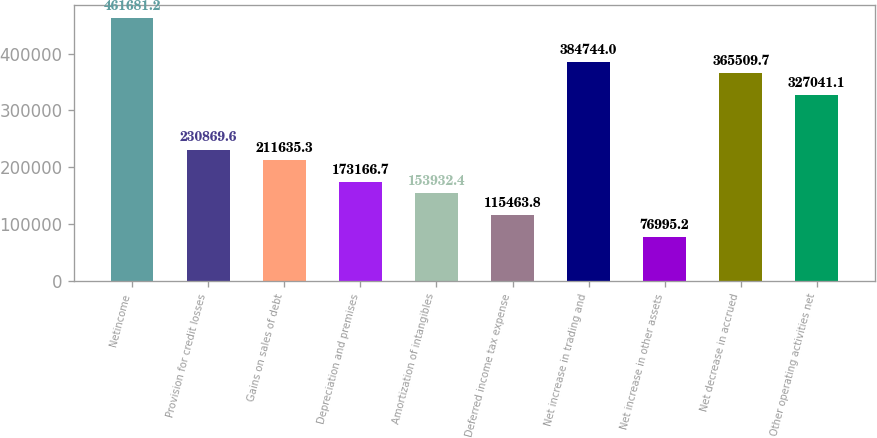<chart> <loc_0><loc_0><loc_500><loc_500><bar_chart><fcel>Netincome<fcel>Provision for credit losses<fcel>Gains on sales of debt<fcel>Depreciation and premises<fcel>Amortization of intangibles<fcel>Deferred income tax expense<fcel>Net increase in trading and<fcel>Net increase in other assets<fcel>Net decrease in accrued<fcel>Other operating activities net<nl><fcel>461681<fcel>230870<fcel>211635<fcel>173167<fcel>153932<fcel>115464<fcel>384744<fcel>76995.2<fcel>365510<fcel>327041<nl></chart> 